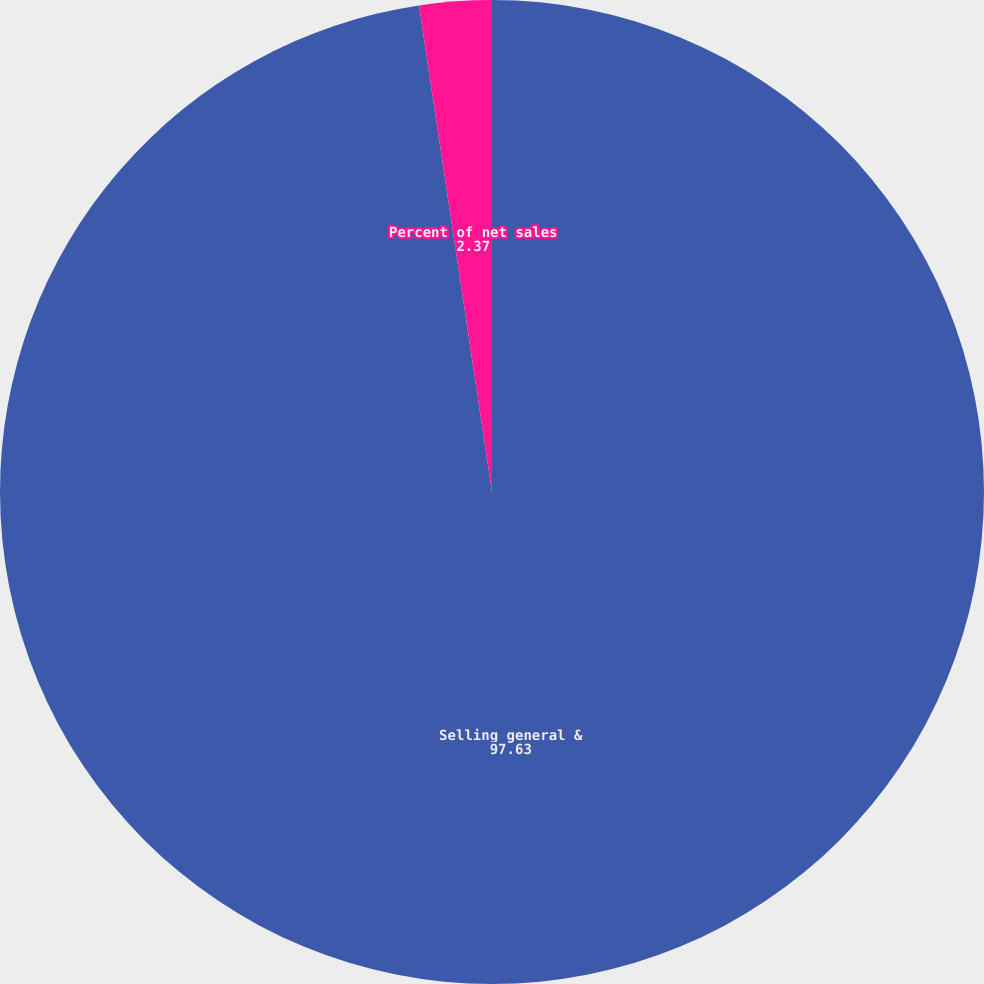<chart> <loc_0><loc_0><loc_500><loc_500><pie_chart><fcel>Selling general &<fcel>Percent of net sales<nl><fcel>97.63%<fcel>2.37%<nl></chart> 